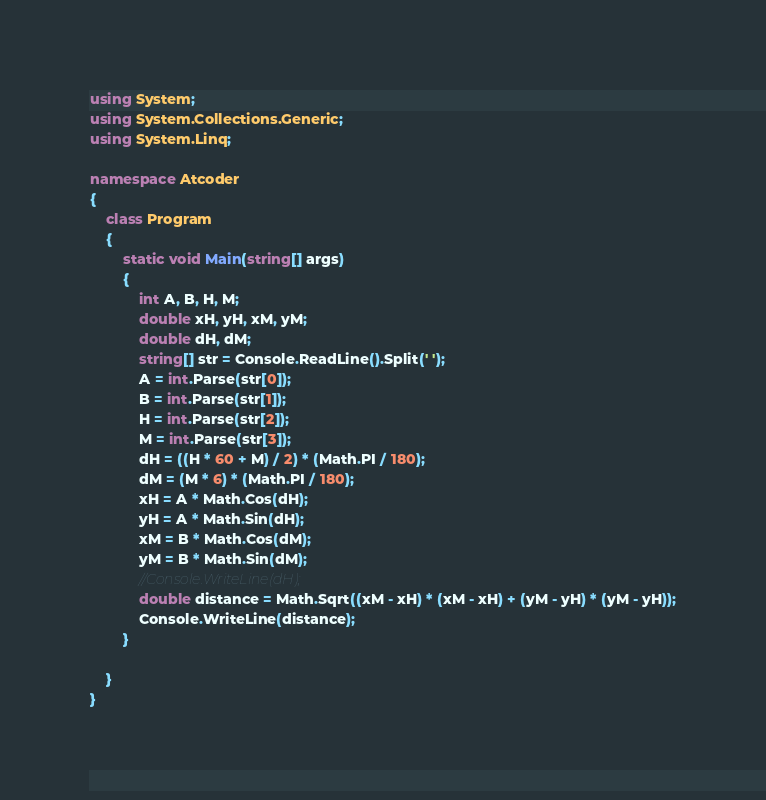<code> <loc_0><loc_0><loc_500><loc_500><_C#_>using System;
using System.Collections.Generic;
using System.Linq;

namespace Atcoder
{
    class Program
    {
        static void Main(string[] args)
        {
            int A, B, H, M;
            double xH, yH, xM, yM;
            double dH, dM;
            string[] str = Console.ReadLine().Split(' ');
            A = int.Parse(str[0]);
            B = int.Parse(str[1]);
            H = int.Parse(str[2]);
            M = int.Parse(str[3]);
            dH = ((H * 60 + M) / 2) * (Math.PI / 180);
            dM = (M * 6) * (Math.PI / 180);
            xH = A * Math.Cos(dH);
            yH = A * Math.Sin(dH);
            xM = B * Math.Cos(dM);
            yM = B * Math.Sin(dM);
            //Console.WriteLine(dH);
            double distance = Math.Sqrt((xM - xH) * (xM - xH) + (yM - yH) * (yM - yH));
            Console.WriteLine(distance);
        }
        
    }
}
</code> 